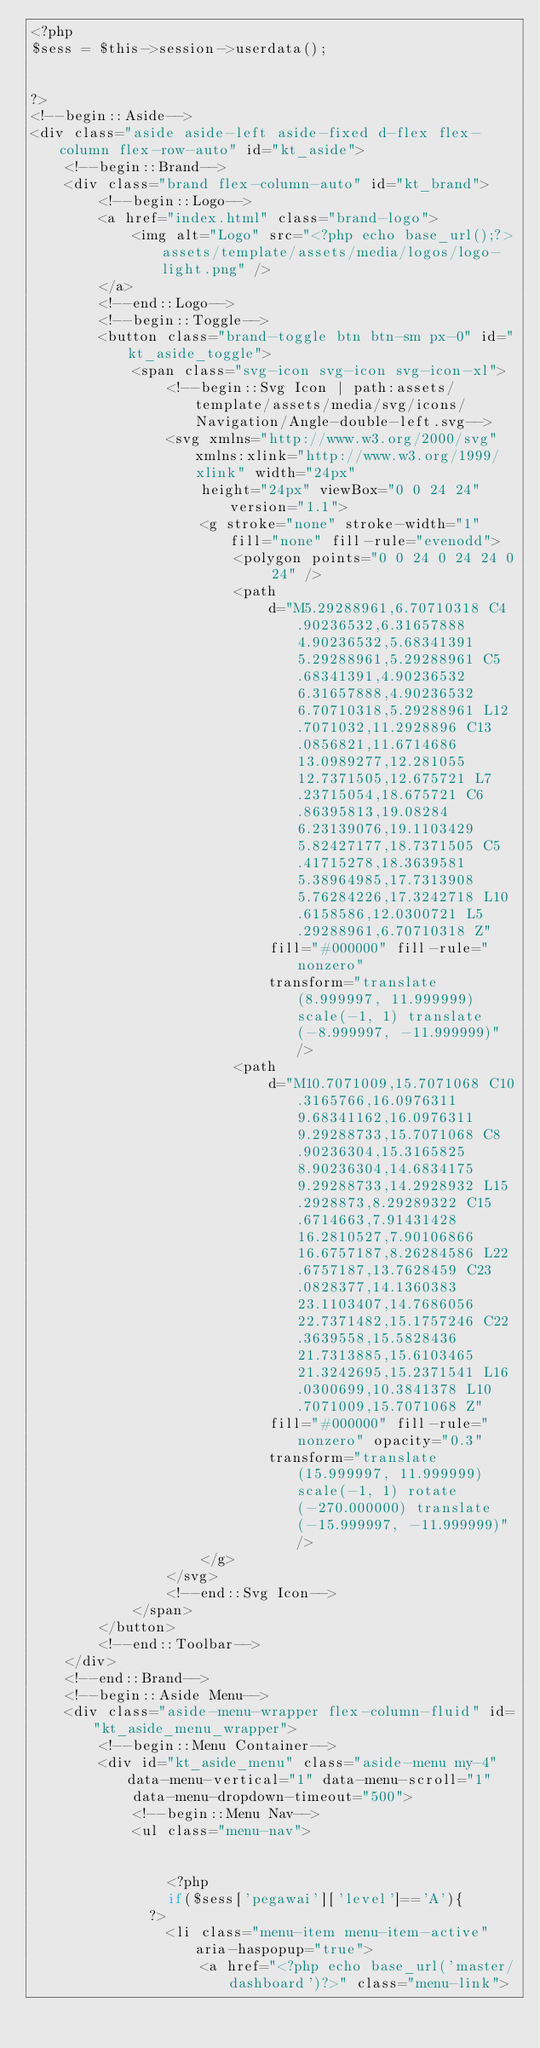<code> <loc_0><loc_0><loc_500><loc_500><_PHP_><?php
$sess = $this->session->userdata();


?>
<!--begin::Aside-->
<div class="aside aside-left aside-fixed d-flex flex-column flex-row-auto" id="kt_aside">
    <!--begin::Brand-->
    <div class="brand flex-column-auto" id="kt_brand">
        <!--begin::Logo-->
        <a href="index.html" class="brand-logo">
            <img alt="Logo" src="<?php echo base_url();?>assets/template/assets/media/logos/logo-light.png" />
        </a>
        <!--end::Logo-->
        <!--begin::Toggle-->
        <button class="brand-toggle btn btn-sm px-0" id="kt_aside_toggle">
            <span class="svg-icon svg-icon svg-icon-xl">
                <!--begin::Svg Icon | path:assets/template/assets/media/svg/icons/Navigation/Angle-double-left.svg-->
                <svg xmlns="http://www.w3.org/2000/svg" xmlns:xlink="http://www.w3.org/1999/xlink" width="24px"
                    height="24px" viewBox="0 0 24 24" version="1.1">
                    <g stroke="none" stroke-width="1" fill="none" fill-rule="evenodd">
                        <polygon points="0 0 24 0 24 24 0 24" />
                        <path
                            d="M5.29288961,6.70710318 C4.90236532,6.31657888 4.90236532,5.68341391 5.29288961,5.29288961 C5.68341391,4.90236532 6.31657888,4.90236532 6.70710318,5.29288961 L12.7071032,11.2928896 C13.0856821,11.6714686 13.0989277,12.281055 12.7371505,12.675721 L7.23715054,18.675721 C6.86395813,19.08284 6.23139076,19.1103429 5.82427177,18.7371505 C5.41715278,18.3639581 5.38964985,17.7313908 5.76284226,17.3242718 L10.6158586,12.0300721 L5.29288961,6.70710318 Z"
                            fill="#000000" fill-rule="nonzero"
                            transform="translate(8.999997, 11.999999) scale(-1, 1) translate(-8.999997, -11.999999)" />
                        <path
                            d="M10.7071009,15.7071068 C10.3165766,16.0976311 9.68341162,16.0976311 9.29288733,15.7071068 C8.90236304,15.3165825 8.90236304,14.6834175 9.29288733,14.2928932 L15.2928873,8.29289322 C15.6714663,7.91431428 16.2810527,7.90106866 16.6757187,8.26284586 L22.6757187,13.7628459 C23.0828377,14.1360383 23.1103407,14.7686056 22.7371482,15.1757246 C22.3639558,15.5828436 21.7313885,15.6103465 21.3242695,15.2371541 L16.0300699,10.3841378 L10.7071009,15.7071068 Z"
                            fill="#000000" fill-rule="nonzero" opacity="0.3"
                            transform="translate(15.999997, 11.999999) scale(-1, 1) rotate(-270.000000) translate(-15.999997, -11.999999)" />
                    </g>
                </svg>
                <!--end::Svg Icon-->
            </span>
        </button>
        <!--end::Toolbar-->
    </div>
    <!--end::Brand-->
    <!--begin::Aside Menu-->
    <div class="aside-menu-wrapper flex-column-fluid" id="kt_aside_menu_wrapper">
        <!--begin::Menu Container-->
        <div id="kt_aside_menu" class="aside-menu my-4" data-menu-vertical="1" data-menu-scroll="1"
            data-menu-dropdown-timeout="500">
            <!--begin::Menu Nav-->
            <ul class="menu-nav">


                <?php 
								if($sess['pegawai']['level']=='A'){
							?>
                <li class="menu-item menu-item-active" aria-haspopup="true">
                    <a href="<?php echo base_url('master/dashboard')?>" class="menu-link"></code> 